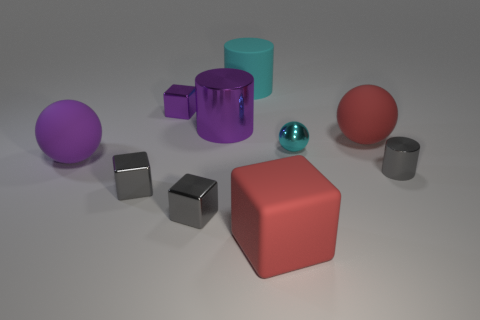Subtract all matte spheres. How many spheres are left? 1 Subtract all gray cylinders. How many gray blocks are left? 2 Subtract all gray cubes. How many cubes are left? 2 Subtract all cubes. How many objects are left? 6 Add 7 big red rubber blocks. How many big red rubber blocks exist? 8 Subtract 1 purple cylinders. How many objects are left? 9 Subtract 1 spheres. How many spheres are left? 2 Subtract all blue cylinders. Subtract all gray spheres. How many cylinders are left? 3 Subtract all gray cubes. Subtract all shiny balls. How many objects are left? 7 Add 8 cyan matte cylinders. How many cyan matte cylinders are left? 9 